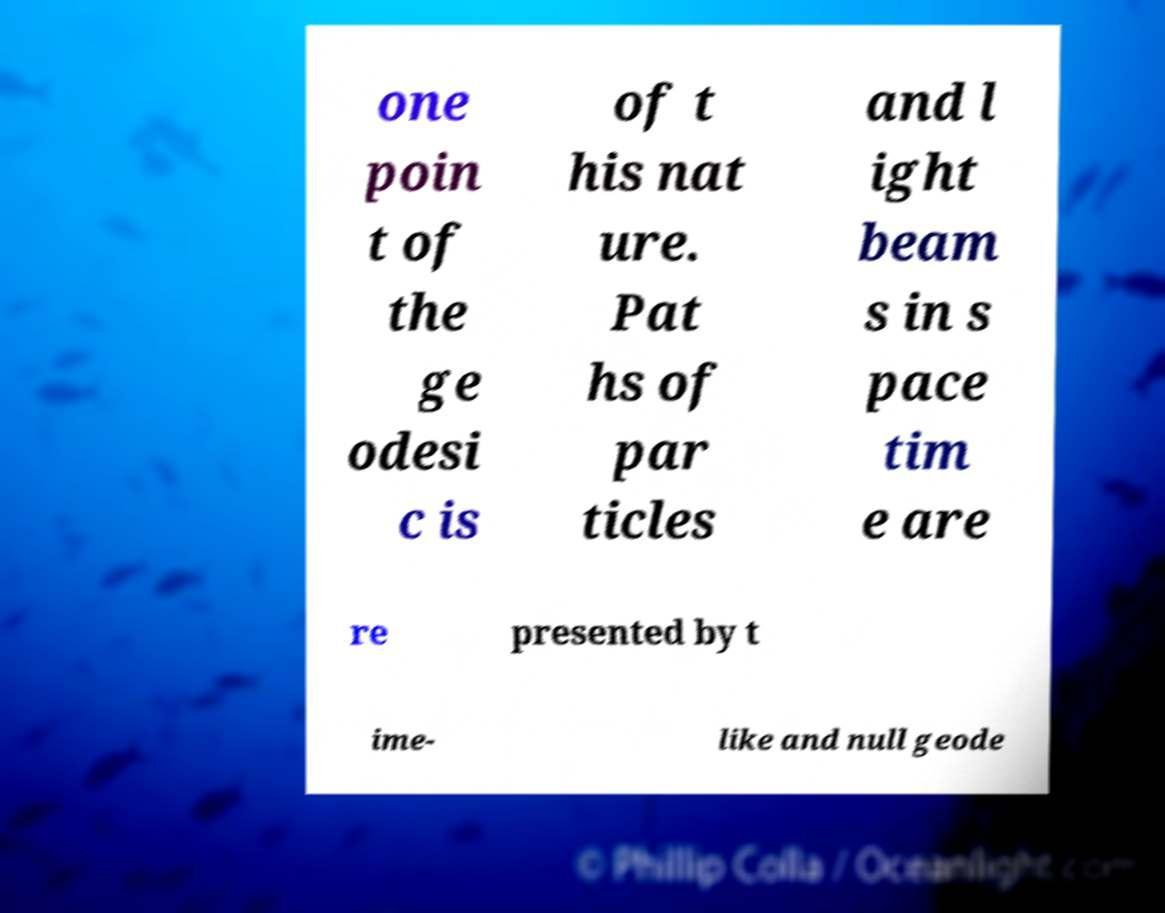Could you extract and type out the text from this image? one poin t of the ge odesi c is of t his nat ure. Pat hs of par ticles and l ight beam s in s pace tim e are re presented by t ime- like and null geode 